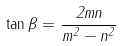Convert formula to latex. <formula><loc_0><loc_0><loc_500><loc_500>\tan { \beta } = { \frac { 2 m n } { m ^ { 2 } - n ^ { 2 } } }</formula> 